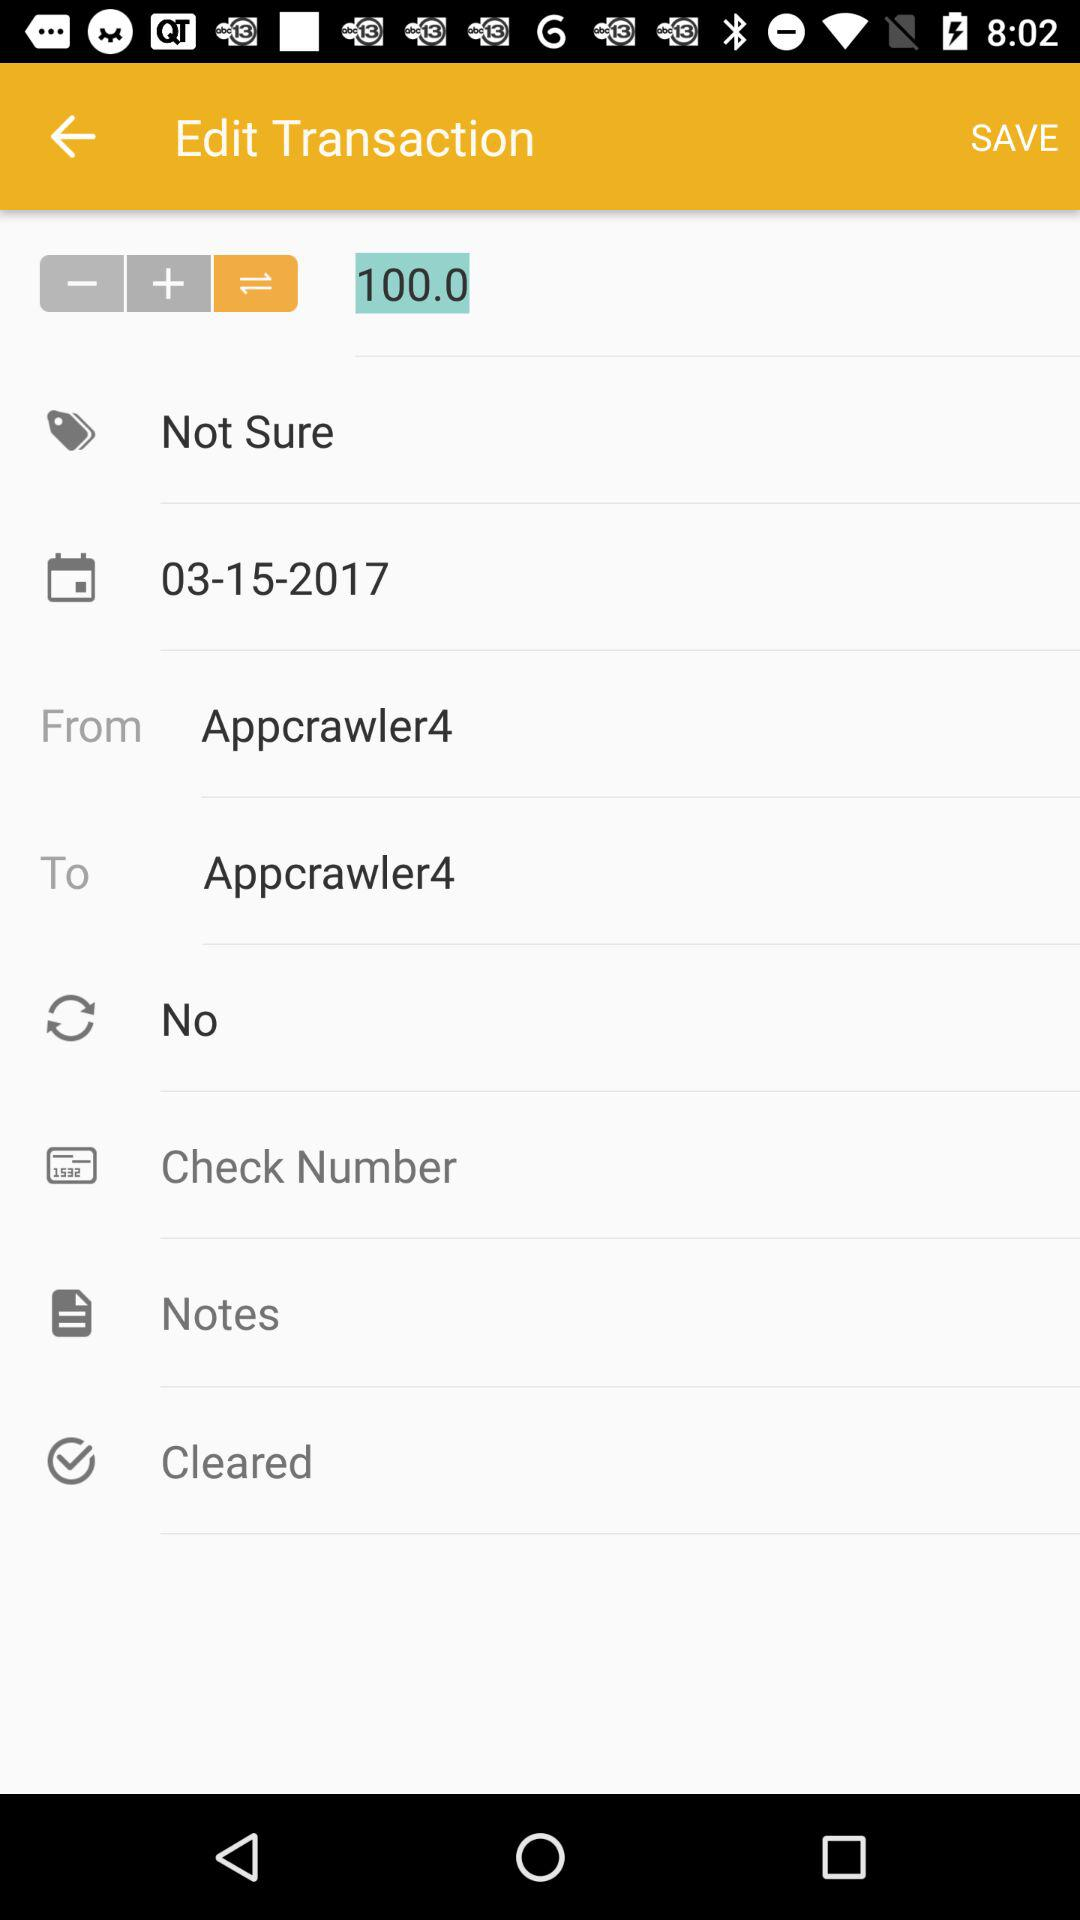What is the selected date? The selected date is 03-15-2017. 